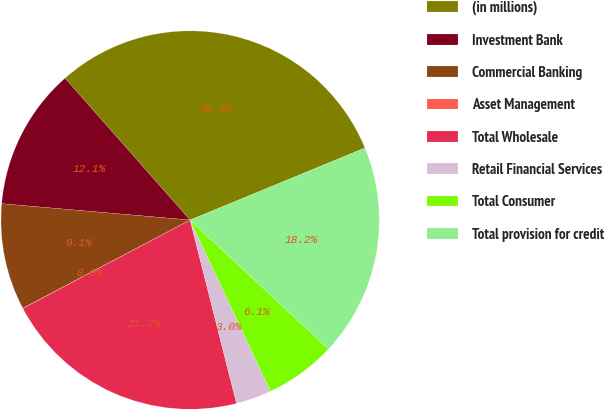<chart> <loc_0><loc_0><loc_500><loc_500><pie_chart><fcel>(in millions)<fcel>Investment Bank<fcel>Commercial Banking<fcel>Asset Management<fcel>Total Wholesale<fcel>Retail Financial Services<fcel>Total Consumer<fcel>Total provision for credit<nl><fcel>30.28%<fcel>12.12%<fcel>9.1%<fcel>0.02%<fcel>21.2%<fcel>3.04%<fcel>6.07%<fcel>18.17%<nl></chart> 